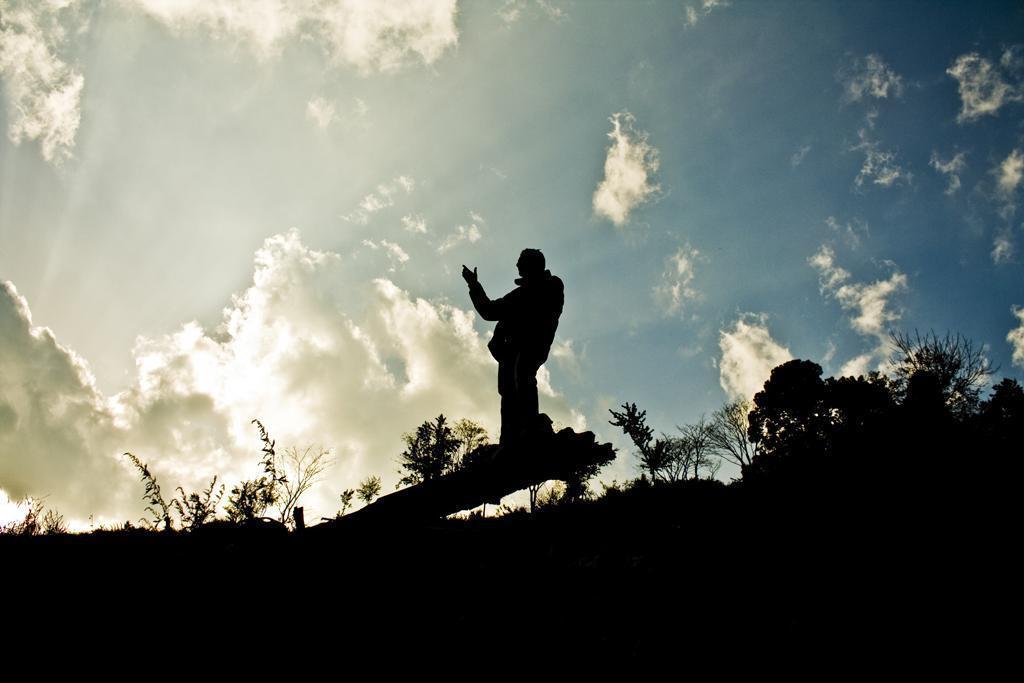Describe this image in one or two sentences. This image is clicked outside. There are trees and plants in the middle. There is a person standing in the middle. There is sky at the top. 